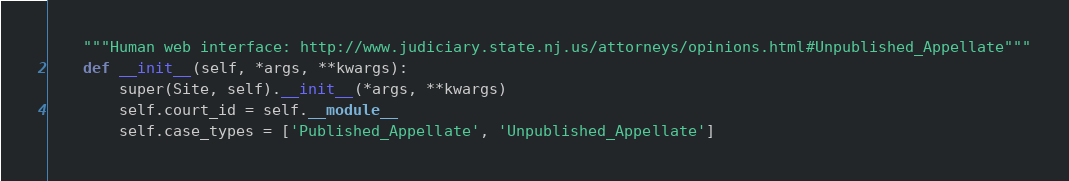Convert code to text. <code><loc_0><loc_0><loc_500><loc_500><_Python_>    """Human web interface: http://www.judiciary.state.nj.us/attorneys/opinions.html#Unpublished_Appellate"""
    def __init__(self, *args, **kwargs):
        super(Site, self).__init__(*args, **kwargs)
        self.court_id = self.__module__
        self.case_types = ['Published_Appellate', 'Unpublished_Appellate']</code> 